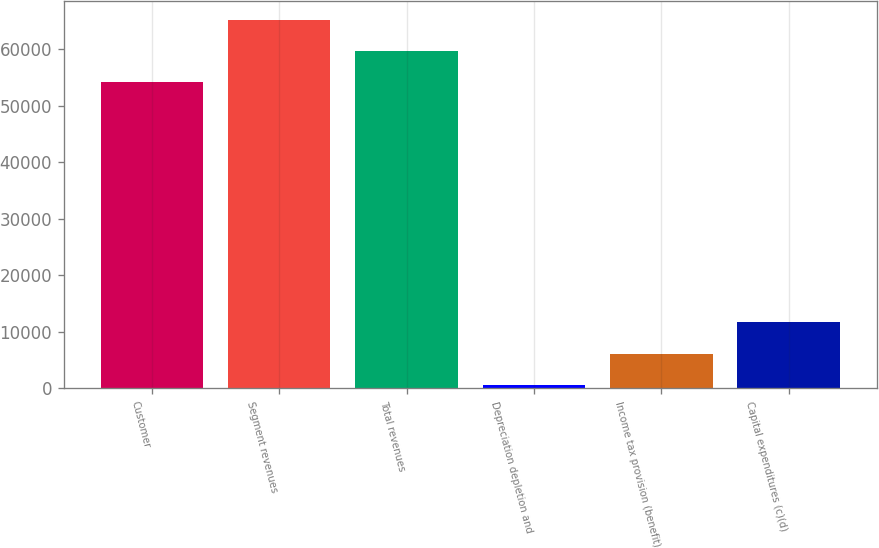Convert chart to OTSL. <chart><loc_0><loc_0><loc_500><loc_500><bar_chart><fcel>Customer<fcel>Segment revenues<fcel>Total revenues<fcel>Depreciation depletion and<fcel>Income tax provision (benefit)<fcel>Capital expenditures (c)(d)<nl><fcel>54137<fcel>65234.6<fcel>59685.8<fcel>587<fcel>6135.8<fcel>11684.6<nl></chart> 